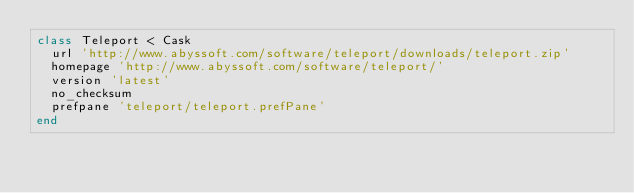Convert code to text. <code><loc_0><loc_0><loc_500><loc_500><_Ruby_>class Teleport < Cask
  url 'http://www.abyssoft.com/software/teleport/downloads/teleport.zip'
  homepage 'http://www.abyssoft.com/software/teleport/'
  version 'latest'
  no_checksum
  prefpane 'teleport/teleport.prefPane'
end
</code> 